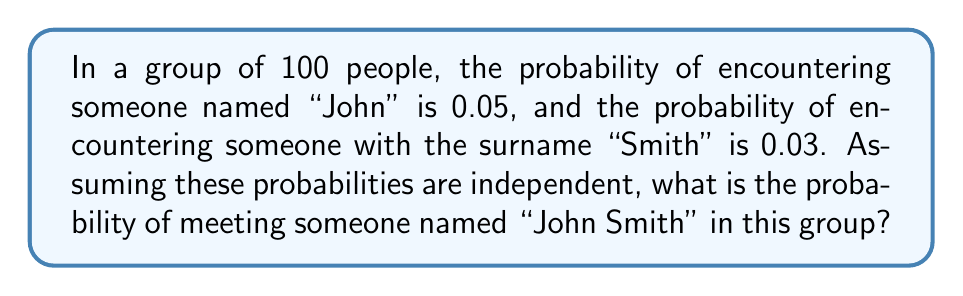Give your solution to this math problem. Let's approach this step-by-step:

1) First, we need to understand what the question is asking. We're looking for the probability of a person having both the first name "John" AND the surname "Smith".

2) We're told that these probabilities are independent, which means the occurrence of one does not affect the probability of the other.

3) When we want the probability of two independent events occurring together, we multiply their individual probabilities.

4) Let's define our events:
   A = the event of a person being named "John"
   B = the event of a person having the surname "Smith"

5) We're given:
   $P(A) = 0.05$
   $P(B) = 0.03$

6) We want to find $P(A \text{ and } B)$, which is equivalent to $P(A \cap B)$

7) For independent events: $P(A \cap B) = P(A) \times P(B)$

8) Therefore:
   $P(\text{John Smith}) = P(A) \times P(B) = 0.05 \times 0.03 = 0.0015$

9) This can be expressed as a percentage: $0.0015 \times 100\% = 0.15\%$

Thus, the probability of encountering someone named "John Smith" in this group is 0.0015 or 0.15%.
Answer: 0.0015 